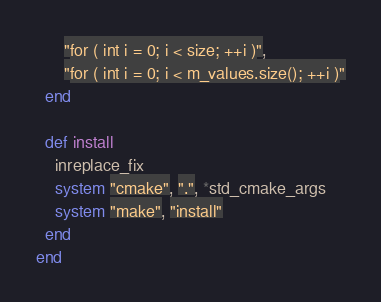<code> <loc_0><loc_0><loc_500><loc_500><_Ruby_>      "for ( int i = 0; i < size; ++i )",
      "for ( int i = 0; i < m_values.size(); ++i )"
  end

  def install
    inreplace_fix
    system "cmake", ".", *std_cmake_args
    system "make", "install"
  end
end
</code> 